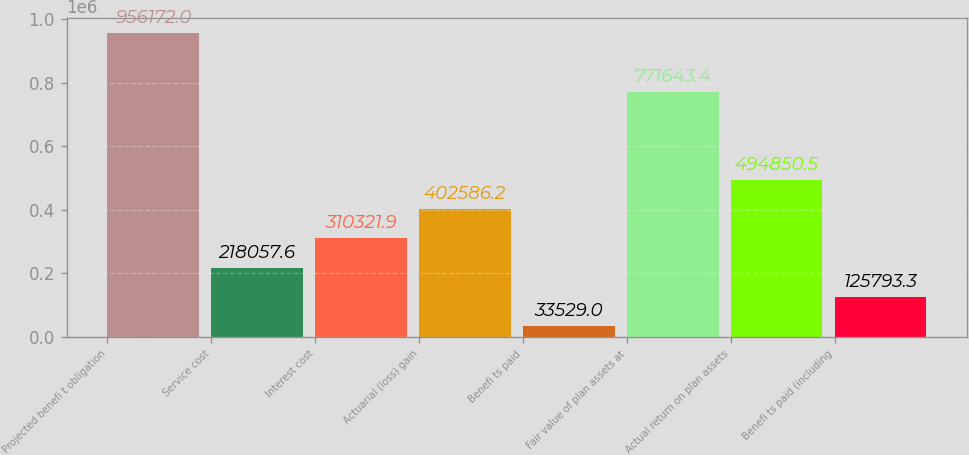Convert chart to OTSL. <chart><loc_0><loc_0><loc_500><loc_500><bar_chart><fcel>Projected benefi t obligation<fcel>Service cost<fcel>Interest cost<fcel>Actuarial (loss) gain<fcel>Benefi ts paid<fcel>Fair value of plan assets at<fcel>Actual return on plan assets<fcel>Benefi ts paid (including<nl><fcel>956172<fcel>218058<fcel>310322<fcel>402586<fcel>33529<fcel>771643<fcel>494850<fcel>125793<nl></chart> 